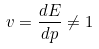Convert formula to latex. <formula><loc_0><loc_0><loc_500><loc_500>v = \frac { d E } { d p } \neq 1</formula> 